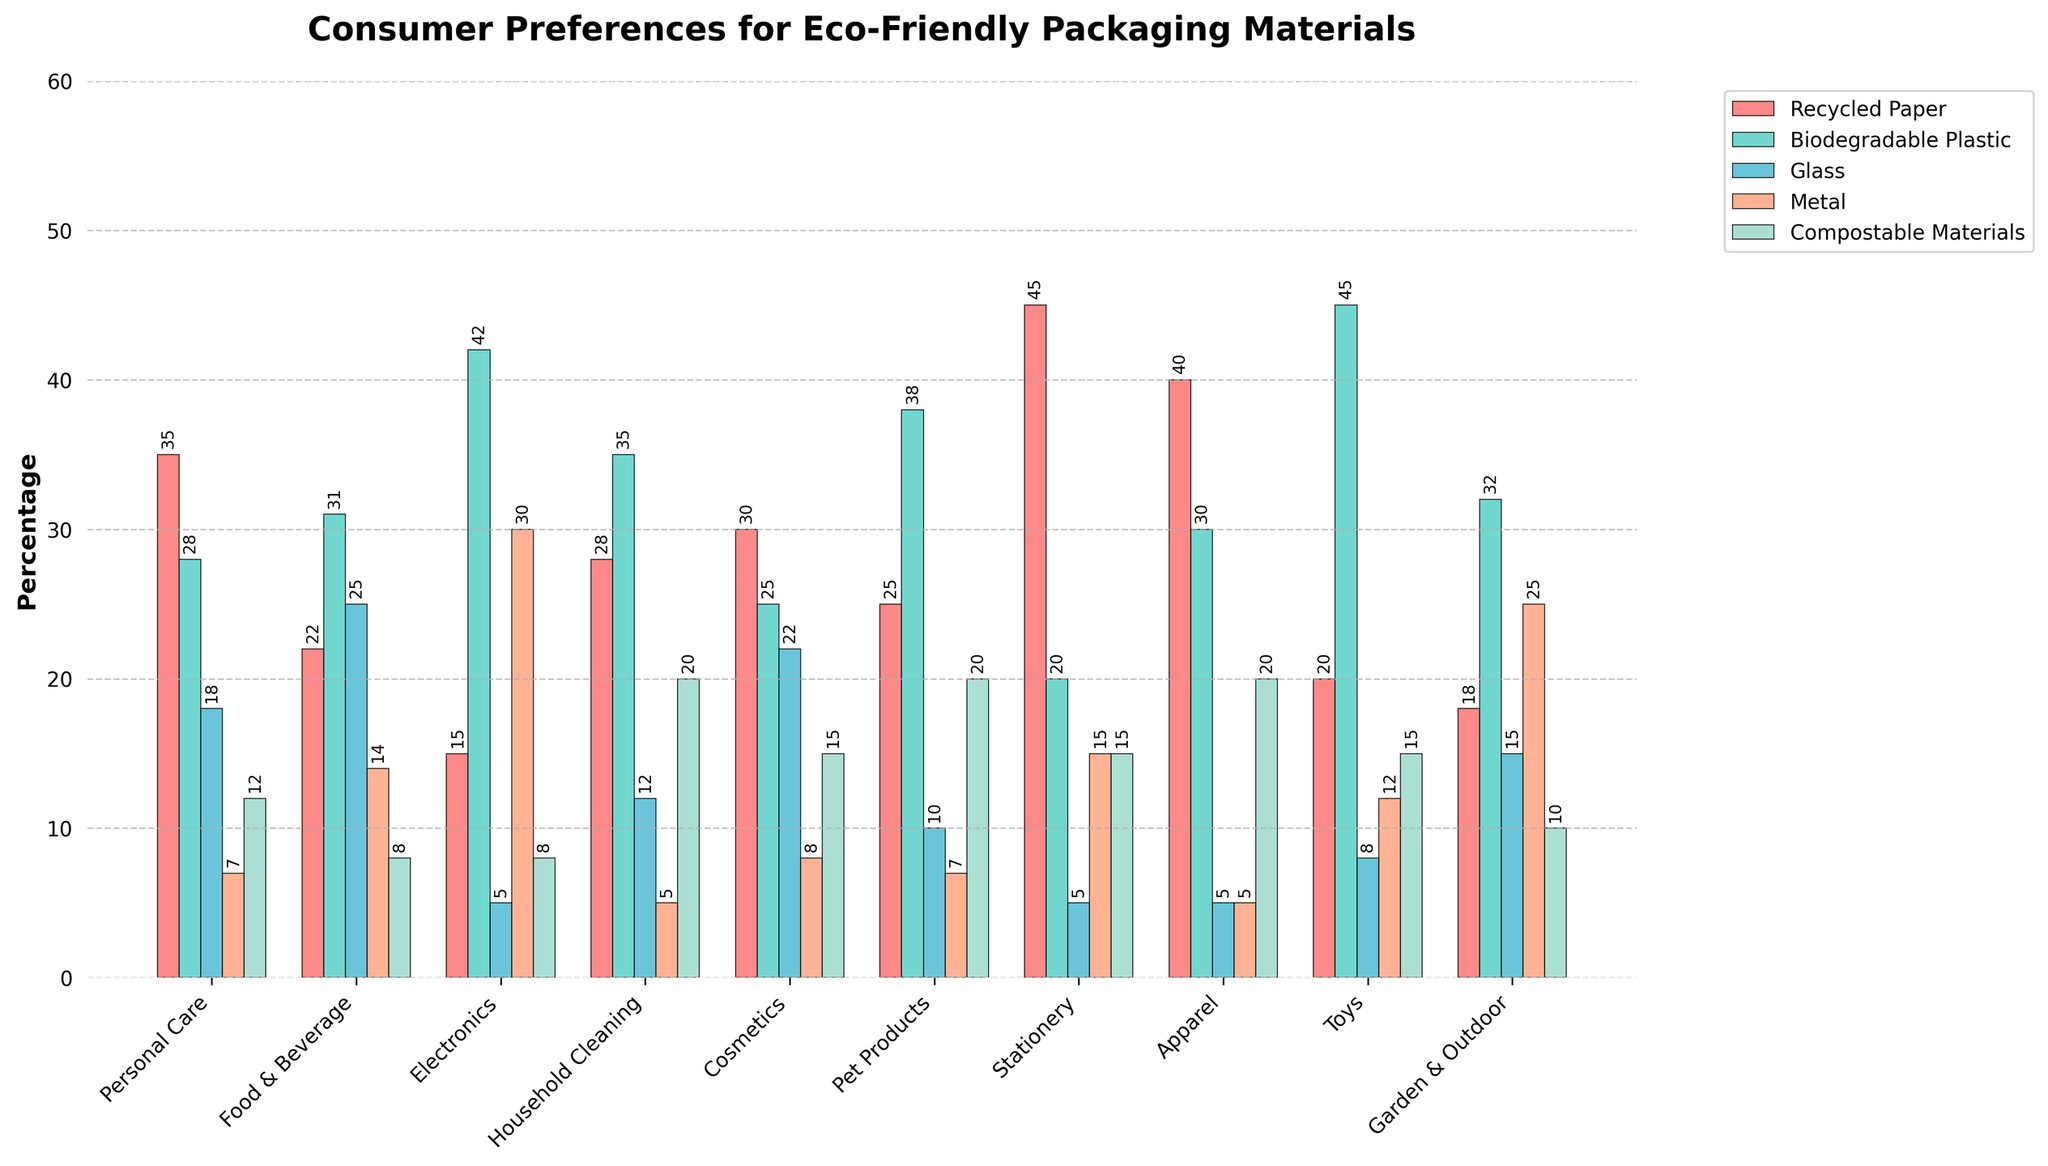How many categories prefer Biodegradable Plastic over Recycled Paper? Check each category where the bar for Biodegradable Plastic is taller than that for Recycled Paper. These are: Electronics, Pet Products, Toys, and Garden & Outdoor. Count these categories.
Answer: 4 Which product category shows the highest preference for Recycled Paper? Look for the tallest red bar representing Recycled Paper among all categories. It is in the Stationery category.
Answer: Stationery Is Glass more preferred than Metal in any categories? List them. Compare the height of the blue bar (Glass) with the height of the orange bar (Metal) in each category. Glass is more preferred than Metal in these categories: Food & Beverage, Cosmetics, and Garden & Outdoor.
Answer: Food & Beverage, Cosmetics, Garden & Outdoor What is the average preference percentage for Compostable Materials across all categories? Sum the percentages of Compostable Materials for all categories: 12 + 8 + 8 + 20 + 15 + 20 + 15 + 20 + 15 + 10 = 143. Then divide by the number of categories, which is 10.
Answer: 14.3 Which two categories have the smallest preference for any material, and what is that preference? Identify the smallest bars across all categories. The smallest preferences are for Metal in Personal Care and Stationery, both at 5%.
Answer: Personal Care, Stationery; Metal, 5% For which product category is the preference for Metal closest to 10%? Look for categories where the orange bar (Metal) is closest to the 10% mark. In this case, Pet Products have a 7% preference for Metal, which is closest to 10%.
Answer: Pet Products Which product category has the largest difference between preferences for Recycled Paper and Biodegradable Plastic? Calculate the absolute difference between Recycled Paper and Biodegradable Plastic percentages for each category and identify the category with the largest difference. The differences are: Personal Care (7), Food & Beverage (9), Electronics (27), Household Cleaning (7), Cosmetics (5), Pet Products (13), Stationery (25), Apparel (10), Toys (25), Garden & Outdoor (14). The largest difference is in Electronics, with a difference of 27.
Answer: Electronics In how many categories is the preference for Compostable Materials higher than 15%? Identify and count the categories where the green bar (Compostable Materials) is above the 15% mark. These are Household Cleaning, Pet Products, Stationery, and Apparel.
Answer: 4 